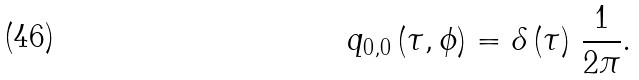<formula> <loc_0><loc_0><loc_500><loc_500>q _ { 0 , 0 } \left ( \tau , \phi \right ) = \delta \left ( \tau \right ) \, \frac { 1 } { 2 \pi } .</formula> 